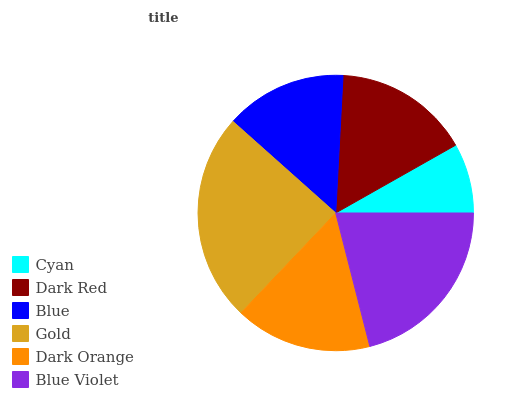Is Cyan the minimum?
Answer yes or no. Yes. Is Gold the maximum?
Answer yes or no. Yes. Is Dark Red the minimum?
Answer yes or no. No. Is Dark Red the maximum?
Answer yes or no. No. Is Dark Red greater than Cyan?
Answer yes or no. Yes. Is Cyan less than Dark Red?
Answer yes or no. Yes. Is Cyan greater than Dark Red?
Answer yes or no. No. Is Dark Red less than Cyan?
Answer yes or no. No. Is Dark Orange the high median?
Answer yes or no. Yes. Is Dark Red the low median?
Answer yes or no. Yes. Is Blue the high median?
Answer yes or no. No. Is Dark Orange the low median?
Answer yes or no. No. 